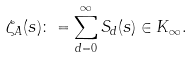<formula> <loc_0><loc_0><loc_500><loc_500>\zeta _ { A } ( s ) \colon = \sum _ { d = 0 } ^ { \infty } S _ { d } ( s ) \in K _ { \infty } .</formula> 